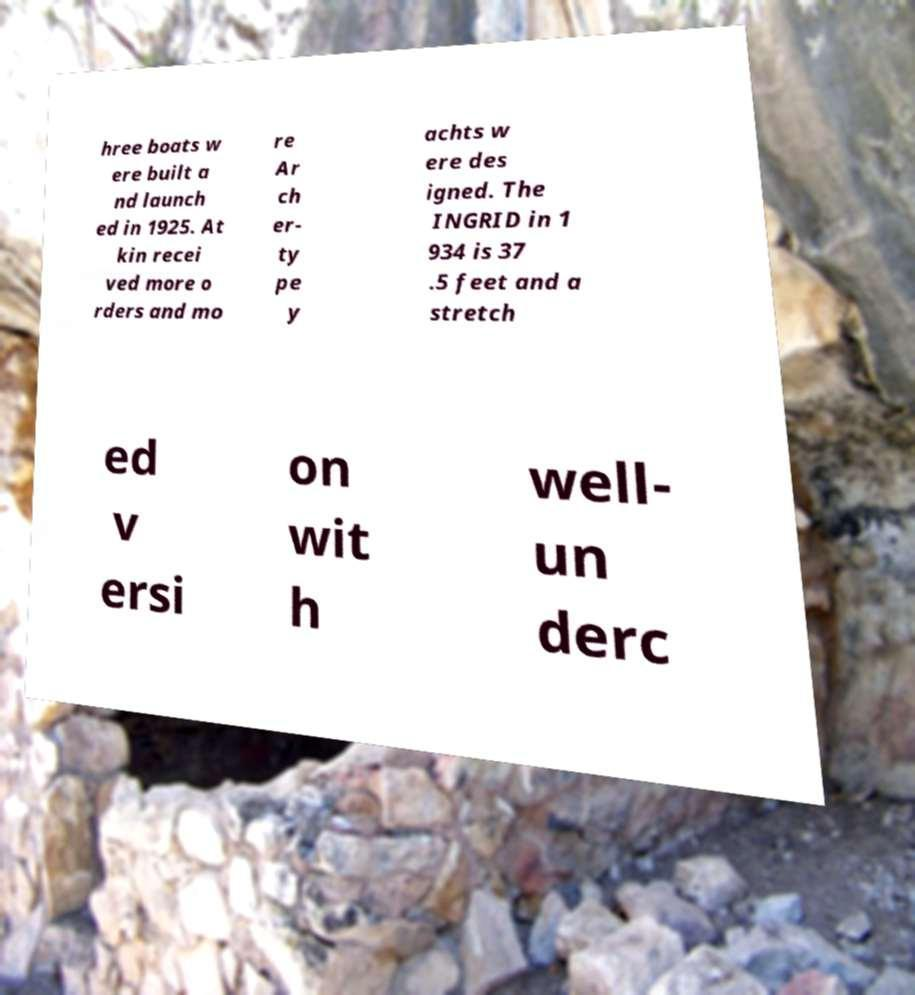Can you accurately transcribe the text from the provided image for me? hree boats w ere built a nd launch ed in 1925. At kin recei ved more o rders and mo re Ar ch er- ty pe y achts w ere des igned. The INGRID in 1 934 is 37 .5 feet and a stretch ed v ersi on wit h well- un derc 